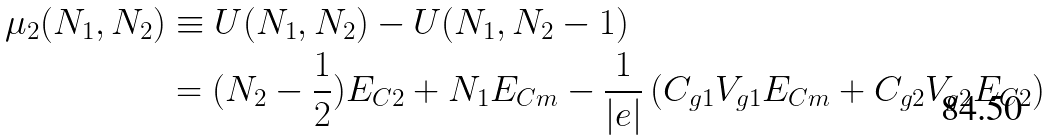Convert formula to latex. <formula><loc_0><loc_0><loc_500><loc_500>\mu _ { 2 } ( N _ { 1 } , N _ { 2 } ) & \equiv U ( N _ { 1 } , N _ { 2 } ) - U ( N _ { 1 } , N _ { 2 } - 1 ) \\ & = ( N _ { 2 } - \frac { 1 } { 2 } ) E _ { C 2 } + N _ { 1 } E _ { C m } - \frac { 1 } { | e | } \left ( C _ { g 1 } V _ { g 1 } E _ { C m } + C _ { g 2 } V _ { g 2 } E _ { C 2 } \right )</formula> 